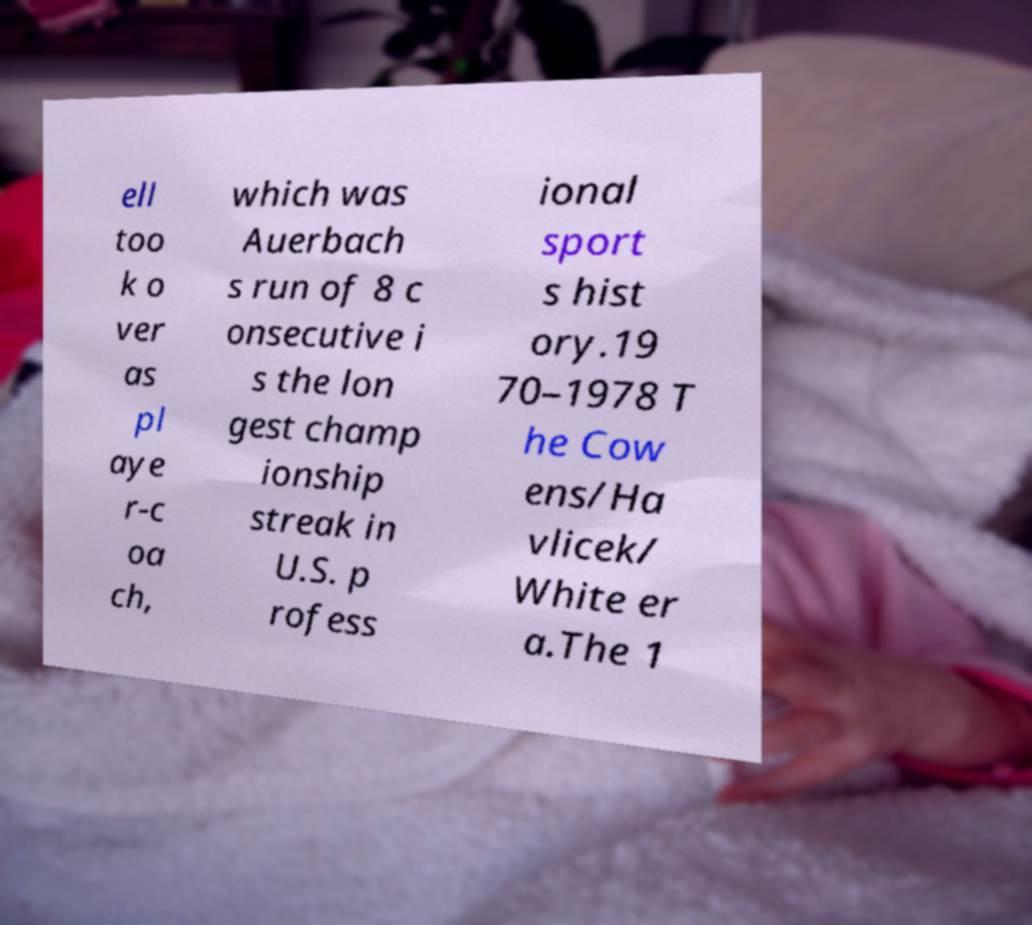Could you assist in decoding the text presented in this image and type it out clearly? ell too k o ver as pl aye r-c oa ch, which was Auerbach s run of 8 c onsecutive i s the lon gest champ ionship streak in U.S. p rofess ional sport s hist ory.19 70–1978 T he Cow ens/Ha vlicek/ White er a.The 1 